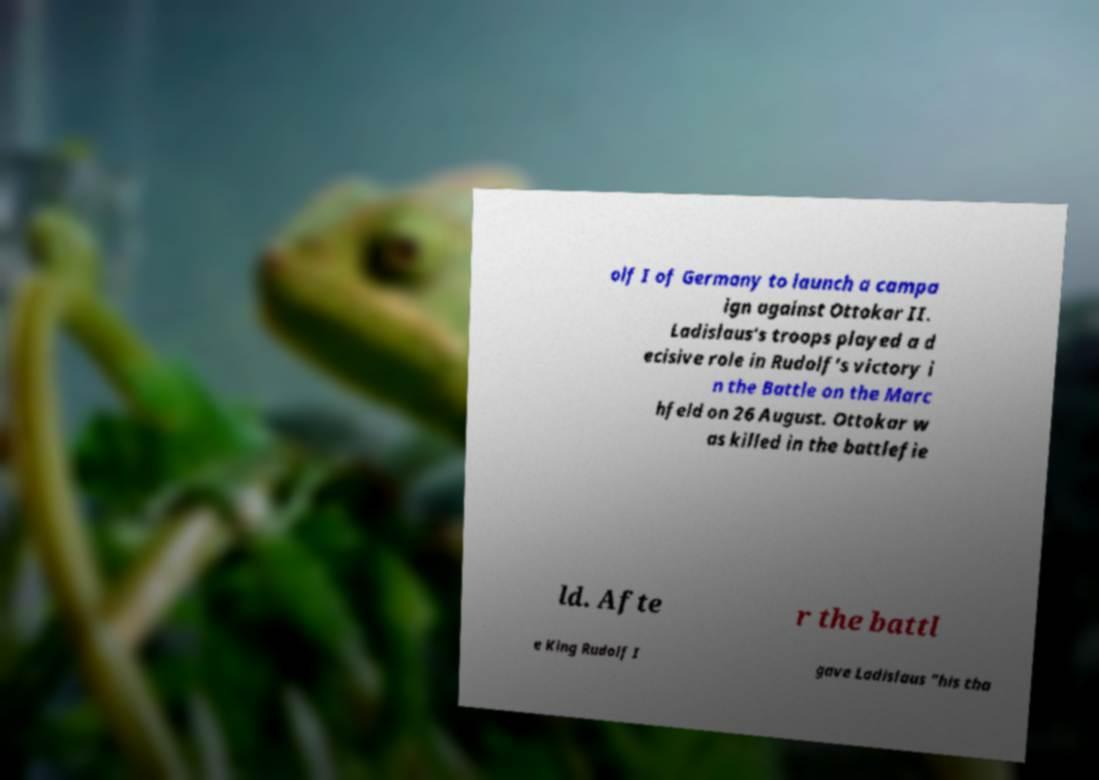What messages or text are displayed in this image? I need them in a readable, typed format. olf I of Germany to launch a campa ign against Ottokar II. Ladislaus's troops played a d ecisive role in Rudolf's victory i n the Battle on the Marc hfeld on 26 August. Ottokar w as killed in the battlefie ld. Afte r the battl e King Rudolf I gave Ladislaus "his tha 